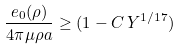<formula> <loc_0><loc_0><loc_500><loc_500>\frac { e _ { 0 } ( \rho ) } { 4 \pi \mu \rho a } \geq ( 1 - C \, Y ^ { 1 / 1 7 } )</formula> 